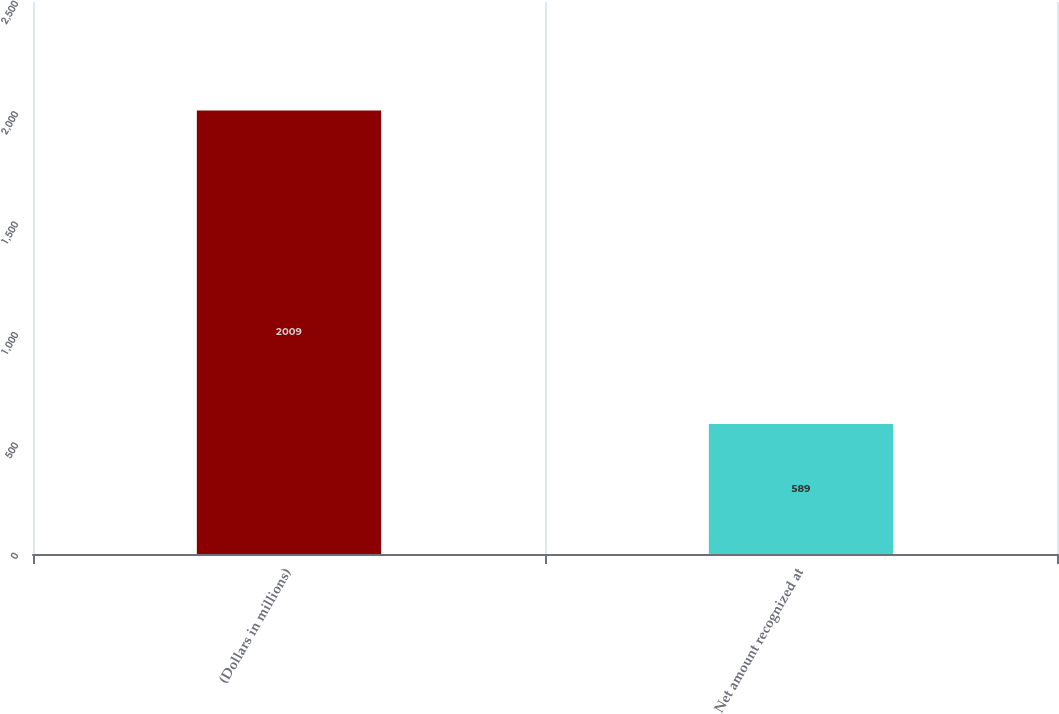Convert chart. <chart><loc_0><loc_0><loc_500><loc_500><bar_chart><fcel>(Dollars in millions)<fcel>Net amount recognized at<nl><fcel>2009<fcel>589<nl></chart> 